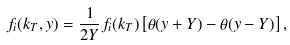<formula> <loc_0><loc_0><loc_500><loc_500>f _ { i } ( k _ { T } , y ) = \frac { 1 } { 2 Y } f _ { i } ( k _ { T } ) \left [ \theta ( y + Y ) - \theta ( y - Y ) \right ] ,</formula> 